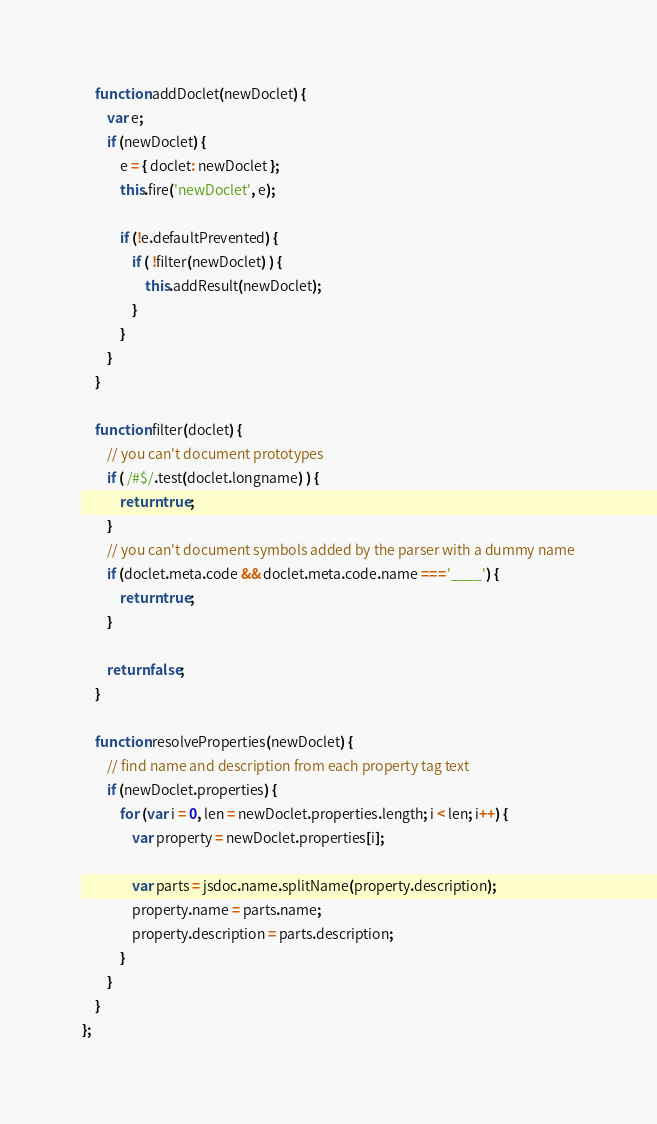<code> <loc_0><loc_0><loc_500><loc_500><_JavaScript_>
    function addDoclet(newDoclet) {
        var e;
        if (newDoclet) {
            e = { doclet: newDoclet };
            this.fire('newDoclet', e);

            if (!e.defaultPrevented) {
                if ( !filter(newDoclet) ) {
                    this.addResult(newDoclet);
                }
            }
        }
    }

    function filter(doclet) {
        // you can't document prototypes
        if ( /#$/.test(doclet.longname) ) {
            return true;
        }
        // you can't document symbols added by the parser with a dummy name
        if (doclet.meta.code && doclet.meta.code.name === '____') {
            return true;
        }

        return false;
    }

    function resolveProperties(newDoclet) {
        // find name and description from each property tag text
        if (newDoclet.properties) {
            for (var i = 0, len = newDoclet.properties.length; i < len; i++) {
                var property = newDoclet.properties[i];

                var parts = jsdoc.name.splitName(property.description);
                property.name = parts.name;
                property.description = parts.description;
            }
        }
    }
};

</code> 